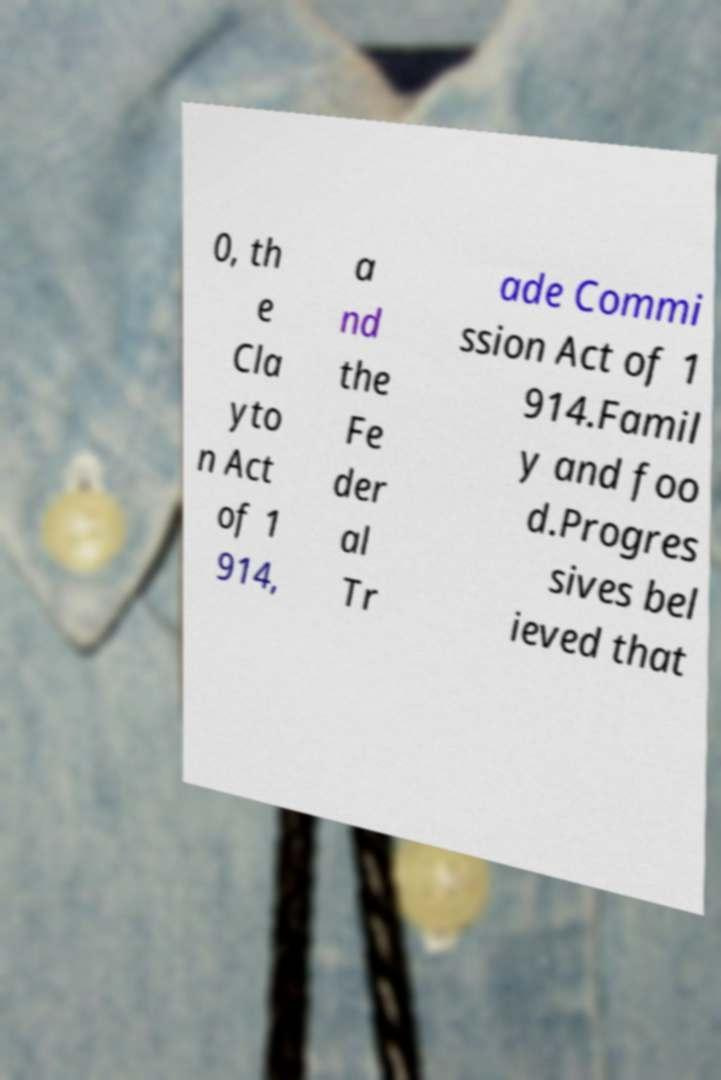Can you read and provide the text displayed in the image?This photo seems to have some interesting text. Can you extract and type it out for me? 0, th e Cla yto n Act of 1 914, a nd the Fe der al Tr ade Commi ssion Act of 1 914.Famil y and foo d.Progres sives bel ieved that 